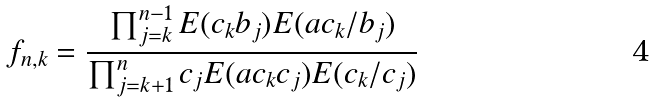<formula> <loc_0><loc_0><loc_500><loc_500>f _ { n , k } = \frac { \prod _ { j = k } ^ { n - 1 } E ( c _ { k } b _ { j } ) E ( a c _ { k } / b _ { j } ) } { \prod _ { j = k + 1 } ^ { n } c _ { j } E ( a c _ { k } c _ { j } ) E ( c _ { k } / c _ { j } ) }</formula> 